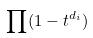<formula> <loc_0><loc_0><loc_500><loc_500>\prod ( 1 - t ^ { d _ { i } } )</formula> 